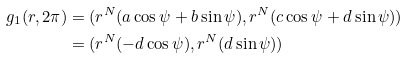Convert formula to latex. <formula><loc_0><loc_0><loc_500><loc_500>g _ { 1 } ( r , 2 \pi ) & = ( r ^ { N } ( a \cos \psi + b \sin \psi ) , r ^ { N } ( c \cos \psi + d \sin \psi ) ) \\ & = ( r ^ { N } ( - d \cos \psi ) , r ^ { N } ( d \sin \psi ) )</formula> 